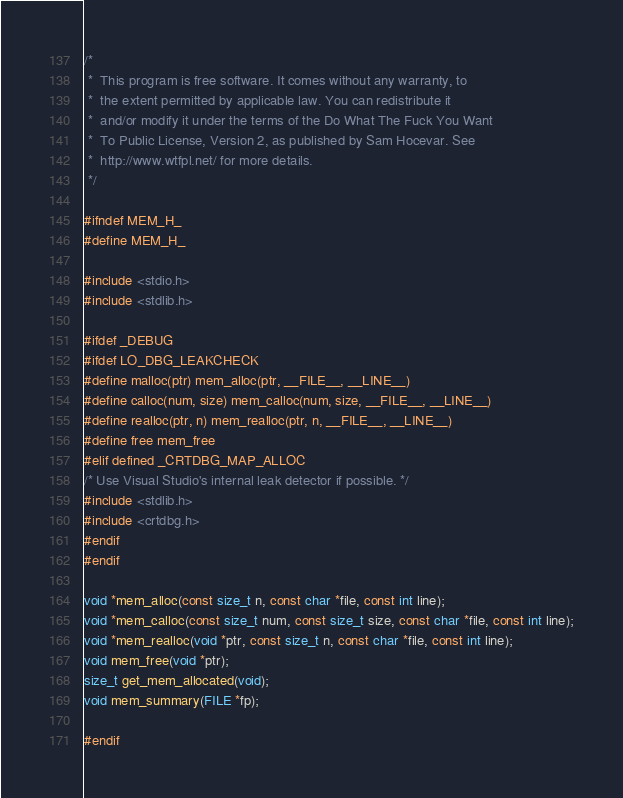<code> <loc_0><loc_0><loc_500><loc_500><_C_>/*
 *  This program is free software. It comes without any warranty, to
 *  the extent permitted by applicable law. You can redistribute it
 *  and/or modify it under the terms of the Do What The Fuck You Want
 *  To Public License, Version 2, as published by Sam Hocevar. See
 *  http://www.wtfpl.net/ for more details.
 */

#ifndef MEM_H_
#define MEM_H_

#include <stdio.h>
#include <stdlib.h>

#ifdef _DEBUG
#ifdef LO_DBG_LEAKCHECK
#define malloc(ptr) mem_alloc(ptr, __FILE__, __LINE__)
#define calloc(num, size) mem_calloc(num, size, __FILE__, __LINE__)
#define realloc(ptr, n) mem_realloc(ptr, n, __FILE__, __LINE__)
#define free mem_free
#elif defined _CRTDBG_MAP_ALLOC
/* Use Visual Studio's internal leak detector if possible. */
#include <stdlib.h>
#include <crtdbg.h>
#endif
#endif

void *mem_alloc(const size_t n, const char *file, const int line);
void *mem_calloc(const size_t num, const size_t size, const char *file, const int line);
void *mem_realloc(void *ptr, const size_t n, const char *file, const int line);
void mem_free(void *ptr);
size_t get_mem_allocated(void);
void mem_summary(FILE *fp);

#endif</code> 